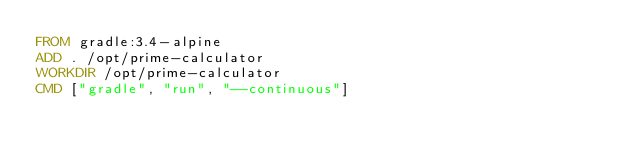<code> <loc_0><loc_0><loc_500><loc_500><_Dockerfile_>FROM gradle:3.4-alpine
ADD . /opt/prime-calculator
WORKDIR /opt/prime-calculator
CMD ["gradle", "run", "--continuous"]</code> 